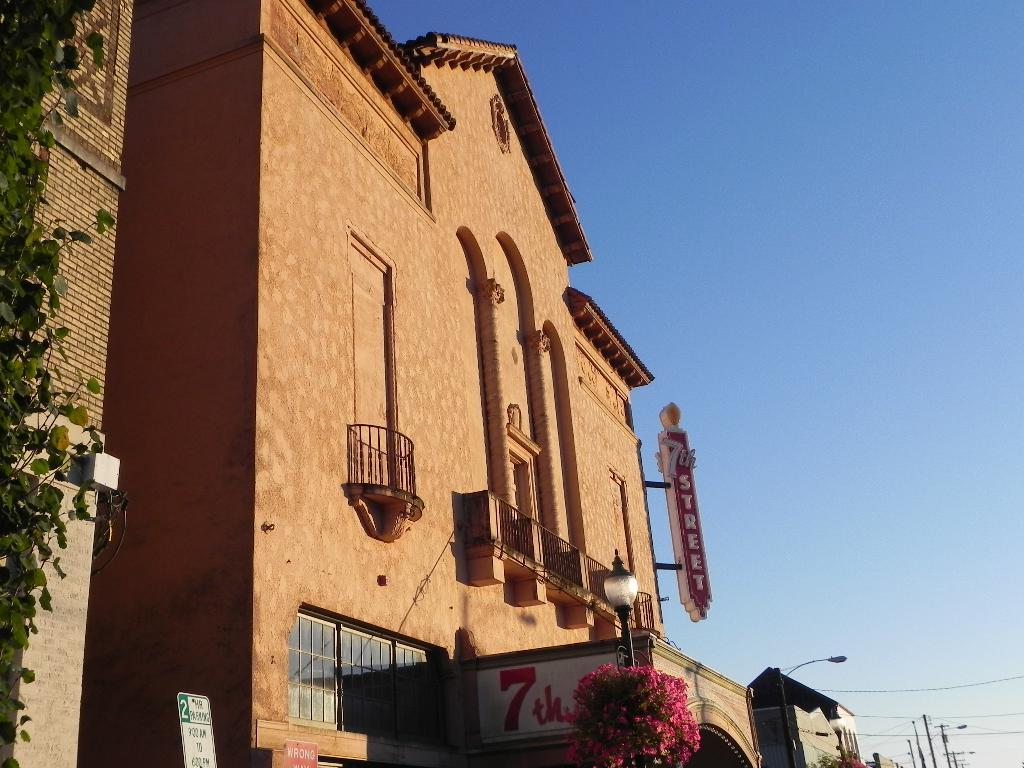What type of structures can be seen in the image? There are buildings in the image. What architectural feature can be seen on the buildings? There are windows visible on the buildings. What other objects can be seen in the image? There are boards and light poles in the image. What type of vegetation is present in the image? There are flowers in the image. What part of the natural environment is visible in the image? The sky is visible in the image. What type of hair can be seen on the lamp in the image? There is no lamp present in the image, and therefore no hair can be observed on it. 